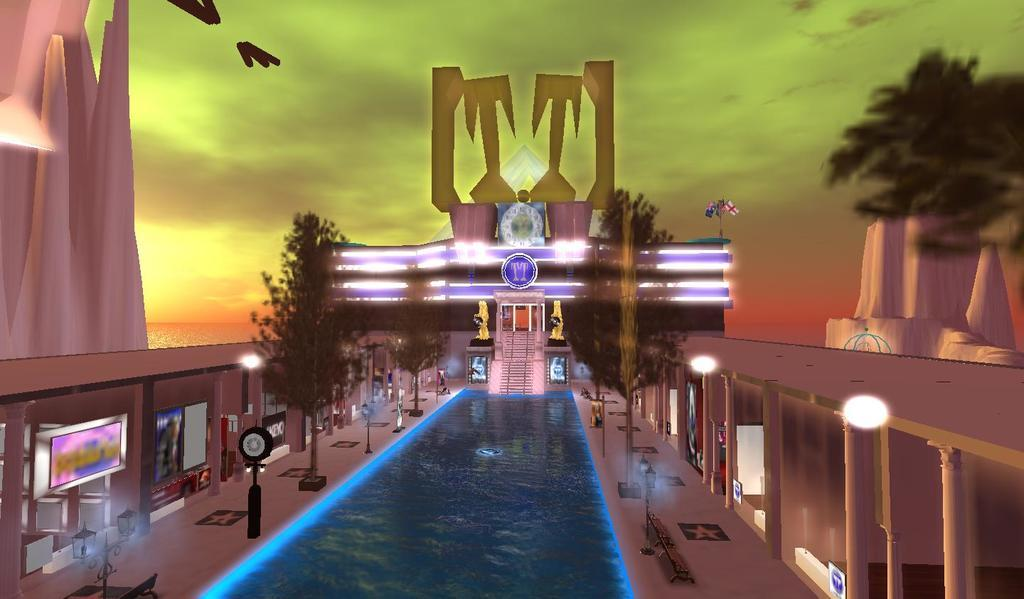What type of image is being described? The image is graphical in nature. What natural element can be seen in the image? There is water visible in the image. What type of vegetation is present in the image? There are trees in the image. What man-made structures are visible in the image? There are poles and buildings in the image. What atmospheric elements can be seen in the image? There are clouds in the image, and the sky is visible. What direction is the monkey facing in the image? There is no monkey present in the image. What type of music is the band playing in the image? There is no band present in the image. 